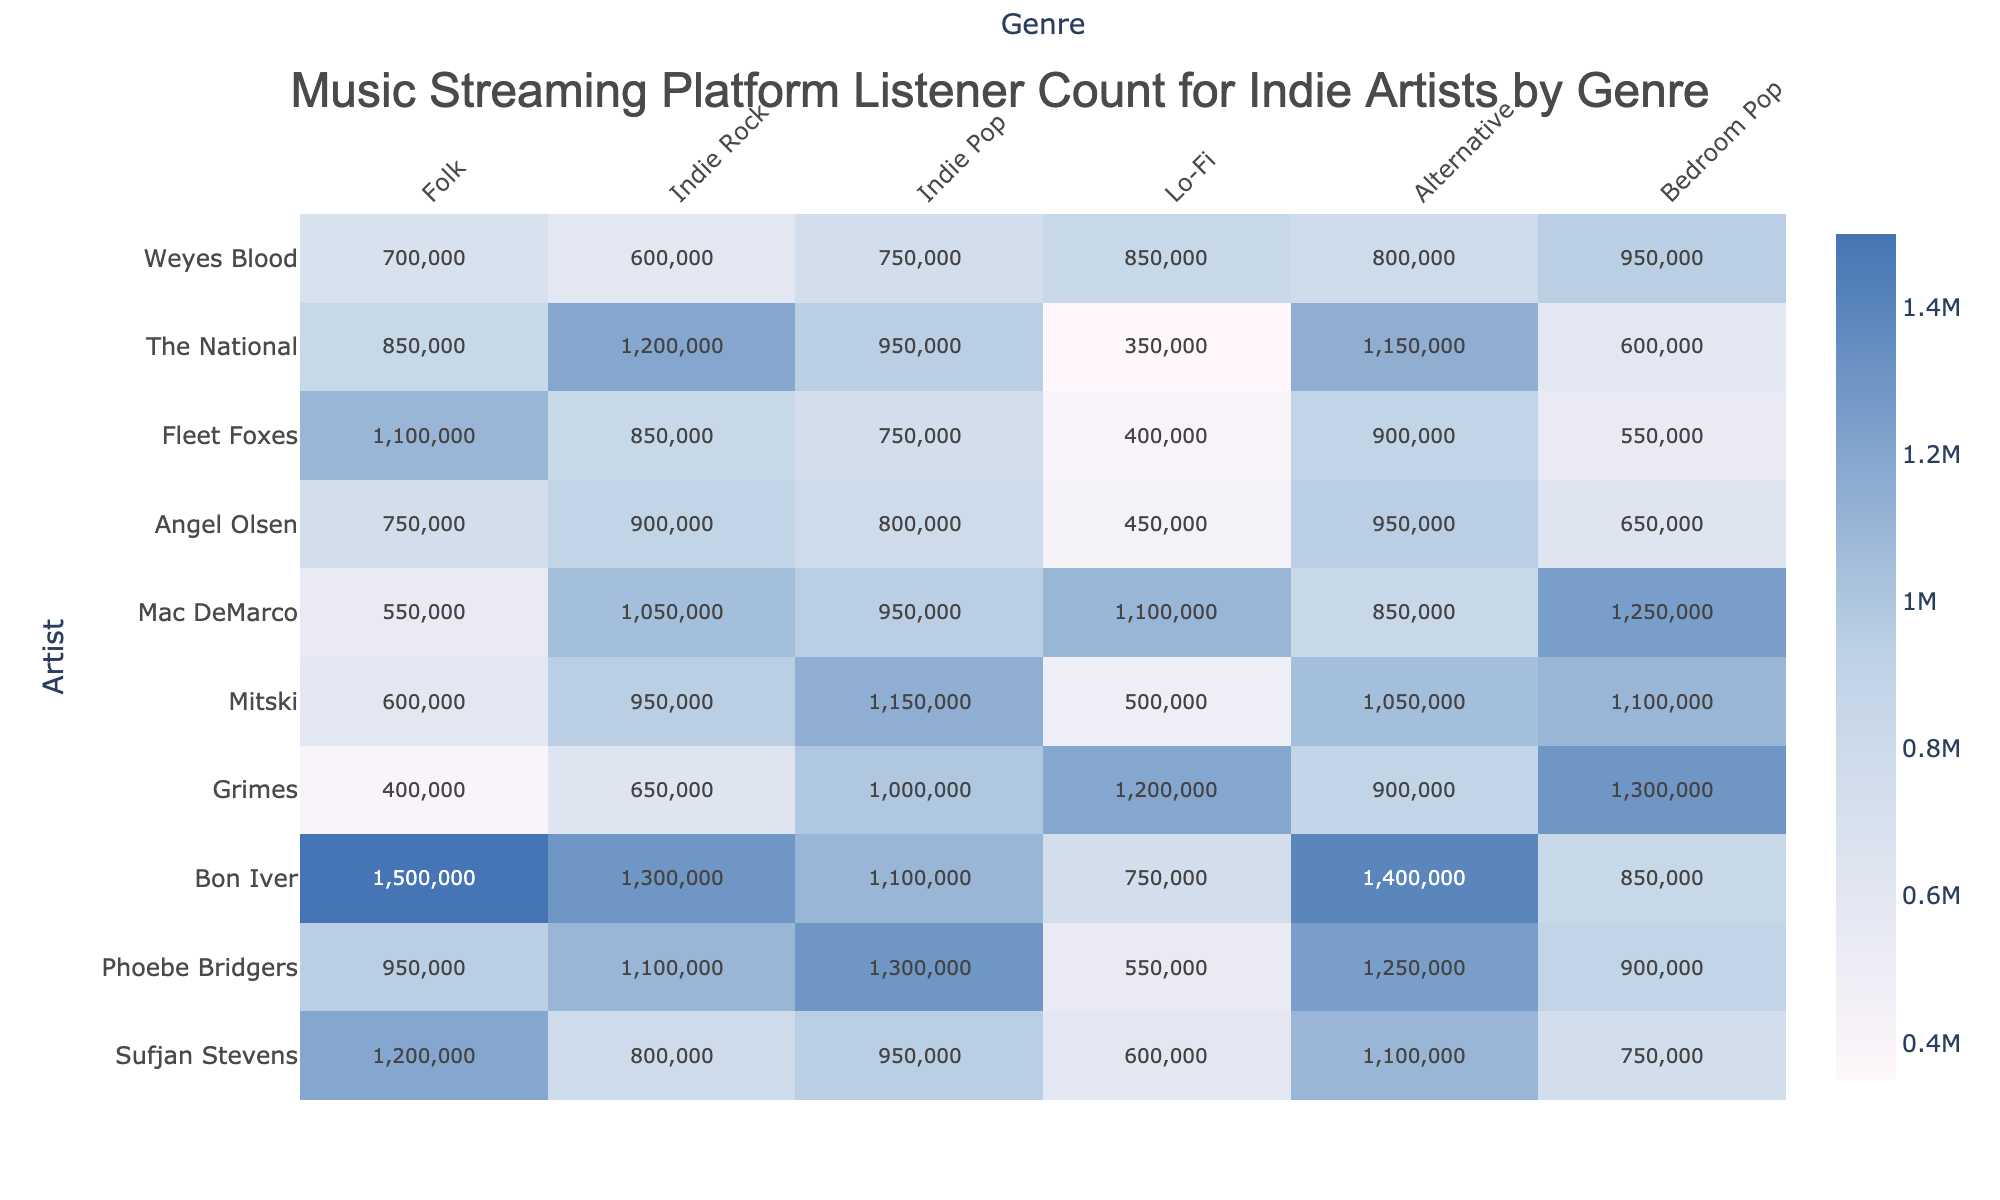What is the listener count for Phoebe Bridgers in the Indie Pop genre? By locating Phoebe Bridgers in the table and reading across to the Indie Pop genre, we see that her listener count is 1,300,000.
Answer: 1,300,000 Which artist has the highest listener count in the Folk genre? By checking the Folk listener counts for each artist in the table, we find Bon Iver with 1,500,000, which is the maximum compared to others.
Answer: Bon Iver How many listeners does Mac DeMarco have in total across all genres? Adding the listener counts for Mac DeMarco across the genres: 550,000 + 1,050,000 + 950,000 + 1,100,000 + 850,000 + 1,250,000 gives us 5,850,000.
Answer: 5,850,000 Is the listener count for Grimes in the Bedroom Pop genre greater than 1,200,000? Looking directly at Grimes' data for Bedroom Pop, it shows 1,300,000, which is indeed greater than 1,200,000.
Answer: Yes What is the difference in listener count between Sufjan Stevens in the Folk genre and The National in the same genre? Sufjan Stevens has 1,200,000 listeners and The National has 850,000. The difference is 1,200,000 - 850,000 = 350,000.
Answer: 350,000 Calculate the average listener count for all artists in the Alternative genre. Summing the counts for the Alternative genre: 1,100,000 + 1,250,000 + 1,400,000 + 900,000 + 1,050,000 + 850,000 + 950,000 + 1,150,000 gives 9,800,000. Dividing by 8 gives an average of 1,225,000.
Answer: 1,225,000 Which artist has a listener count in Lo-Fi that is lower than 700,000? Checking Lo-Fi data, we find that Angel Olsen (450,000) has a count lower than 700,000.
Answer: Angel Olsen If we compare the listener counts of Bon Iver in Alternative and Indie Pop, which genre has a higher count? Bon Iver has 1,400,000 listeners in Alternative and 1,100,000 in Indie Pop. Since 1,400,000 is greater than 1,100,000, Alternative has a higher count.
Answer: Alternative What is the total listener count for the top 3 artists in Indie Rock? The top 3 artists (Phoebe Bridgers, Bon Iver, and The National) have listener counts of 1,100,000, 1,300,000, and 1,200,000 respectively. Summing these, we find 1,100,000 + 1,300,000 + 1,200,000 = 3,600,000.
Answer: 3,600,000 Are there any artists in the Folk genre with a listener count of exactly one million? Checking the Folk listener counts, we see that no artist has exactly 1,000,000 listeners.
Answer: No 